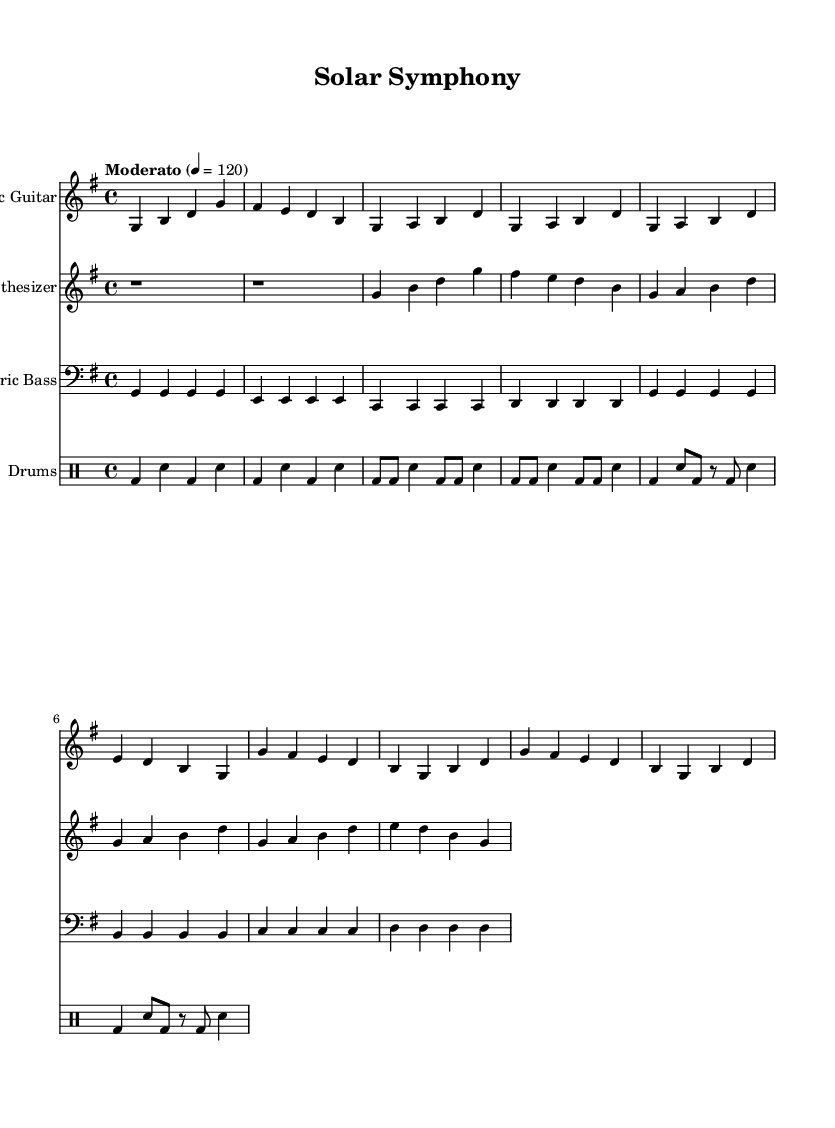What is the key signature of this music? The key signature indicates that there is one sharp, which defines the key as G major.
Answer: G major What is the time signature of this music? The time signature shows four beats per measure, which is represented as 4/4.
Answer: 4/4 What is the tempo marking for the piece? The tempo marking indicates the speed, which is set at a moderate pace of 120 beats per minute.
Answer: Moderato 120 Which instrument plays the first note of the score? The first note is played by the electric guitar, as it is the first staff shown in the sheet music.
Answer: Electric Guitar How many measures are in the electric bass part? Counting the measures in the electric bass line, there are a total of eight measures in the part provided.
Answer: 8 What is the role of the synthesizer in this composition? The synthesizer serves as a background layer, adding harmonic support during the electric guitar and rhythm section melodies.
Answer: Harmonic support How many different instruments are used in this piece? The score includes four distinct instrumental parts: electric guitar, synthesizer, electric bass, and drums.
Answer: 4 